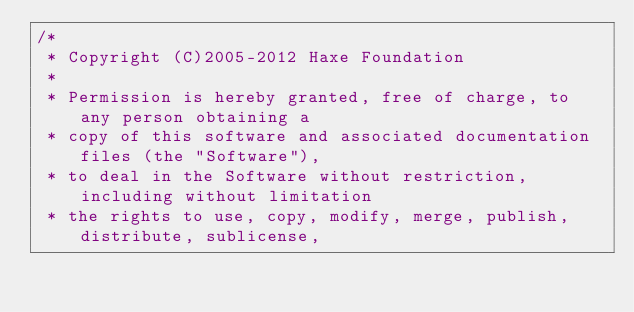<code> <loc_0><loc_0><loc_500><loc_500><_Haxe_>/*
 * Copyright (C)2005-2012 Haxe Foundation
 *
 * Permission is hereby granted, free of charge, to any person obtaining a
 * copy of this software and associated documentation files (the "Software"),
 * to deal in the Software without restriction, including without limitation
 * the rights to use, copy, modify, merge, publish, distribute, sublicense,</code> 